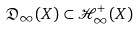<formula> <loc_0><loc_0><loc_500><loc_500>\mathfrak { D } _ { \infty } ( X ) \subset \mathcal { H } ^ { + } _ { \infty } ( X )</formula> 